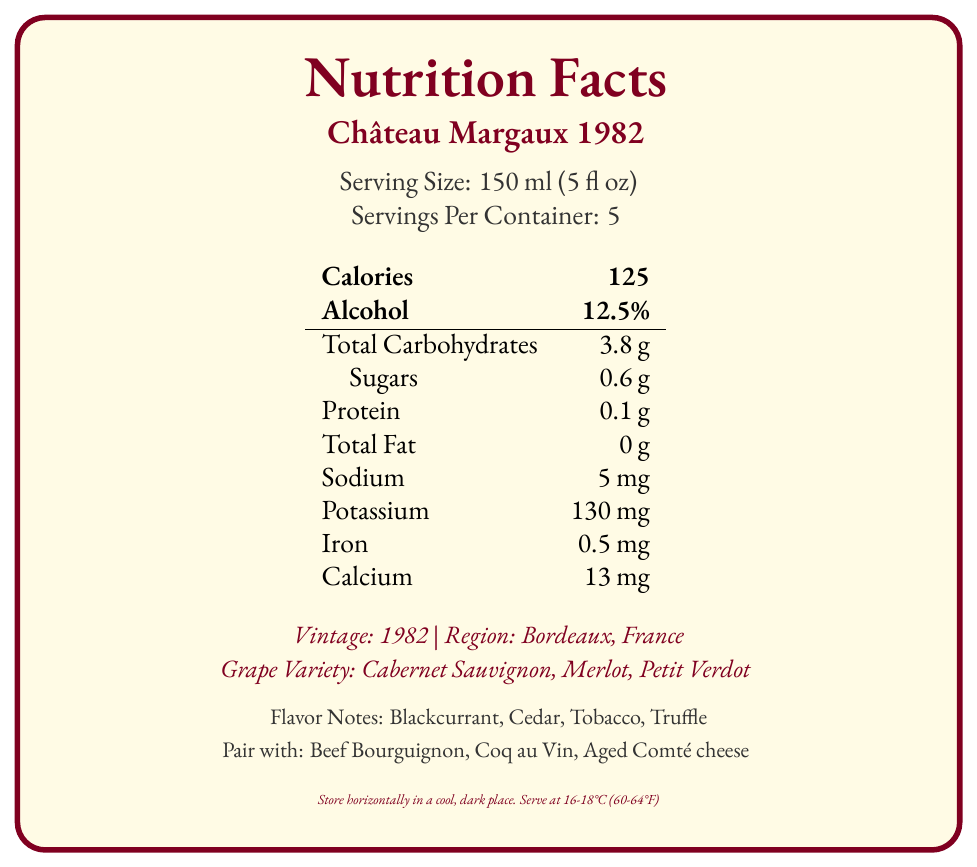what is the serving size? The serving size is explicitly mentioned in the document as "150 ml (5 fl oz)".
Answer: 150 ml (5 fl oz) how many servings are in the container? The document states that there are 5 servings per container.
Answer: 5 how many calories are in one serving? The calorie content per serving is listed in the document as 125 calories.
Answer: 125 what is the alcohol percentage of the wine? The alcohol percentage of the wine is given as 12.5% in the document.
Answer: 12.5% which nutrients are present in the wine? The listed nutrients in the document include Total Carbohydrates, Sugars, Protein, Sodium, Potassium, Iron, and Calcium.
Answer: Carbohydrates, Protein, Sodium, Potassium, Iron, Calcium what is the vintage year of the wine? A. 1982 B. 1990 C. 2000 The document notes the vintage year as 1982.
Answer: A which grape varieties are used in this wine? A. Merlot, Syrah, Cabernet Sauvignon B. Cabernet Sauvignon, Merlot, Petit Verdot C. Pinot Noir, Merlot, Cabernet Franc D. Chardonnay, Pinot Noir, Merlot The document specifies the grape varieties as Cabernet Sauvignon, Merlot, and Petit Verdot.
Answer: B is the wine fat-free? The document lists the total fat as 0 g, indicating that the wine is fat-free.
Answer: Yes summarize the main nutritional information and characteristics of Château Margaux 1982. This summary covers both the nutritional facts and characteristic features of the wine as detailed in the document.
Answer: Château Margaux 1982 has a serving size of 150 ml (5 fl oz) with 125 calories per serving and a 12.5% alcohol content. The wine contains 3.8 g total carbohydrates, 0.6 g sugars, 0.1 g protein, no fat, 5 mg sodium, 130 mg potassium, 0.5 mg iron, and 13 mg calcium. It is a Bordeaux wine made from Cabernet Sauvignon, Merlot, and Petit Verdot grapes, noted for its medium-high tannins and medium acidity. Flavor notes include blackcurrant, cedar, tobacco, and truffle. how much potassium is in one serving? The document specifies that one serving contains 130 mg of potassium.
Answer: 130 mg which food pairings are recommended for this wine? The recommended food pairings listed in the document are Beef Bourguignon, Coq au Vin, and Aged Comté cheese.
Answer: Beef Bourguignon, Coq au Vin, Aged Comté cheese for how long can the wine be aged? The document states that the aging potential for the wine is 30-50 years.
Answer: 30-50 years who is the winemaker? The document mentions that the winemaker is Paul Pontallier.
Answer: Paul Pontallier what is the serving temperature for the wine? The recommended serving temperature is given as 16-18°C (60-64°F).
Answer: 16-18°C (60-64°F) who awarded the wine 100 points? The document notes that Robert Parker awarded the wine 100 points.
Answer: Robert Parker what is the total carbohydrate content per serving? The total carbohydrate content per serving is listed as 3.8 g.
Answer: 3.8 g what is the main flavor profile of the wine? The document describes the main flavor notes as blackcurrant, cedar, tobacco, and truffle.
Answer: Blackcurrant, Cedar, Tobacco, Truffle are there any added sugars in the wine? The document mentions the sugar content but does not specify whether the sugars are naturally occurring or added.
Answer: Cannot be determined what is the closure type of the bottle? The document states that the closure type is a natural cork.
Answer: Natural cork 